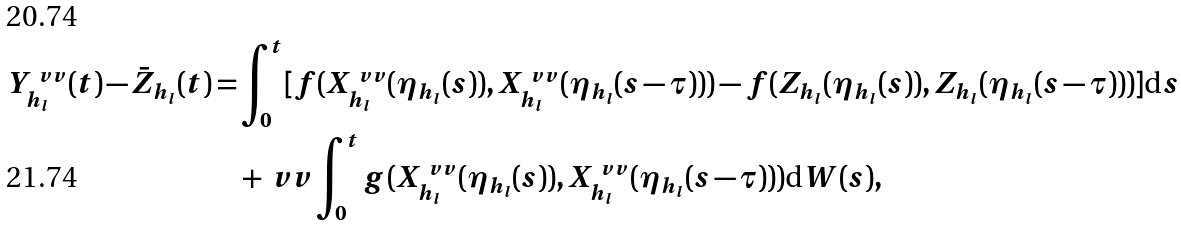Convert formula to latex. <formula><loc_0><loc_0><loc_500><loc_500>Y ^ { \ v v } _ { h _ { l } } ( t ) - \bar { Z } _ { h _ { l } } ( t ) = & \int _ { 0 } ^ { t } [ f ( X ^ { \ v v } _ { h _ { l } } ( \eta _ { h _ { l } } ( s ) ) , X ^ { \ v v } _ { h _ { l } } ( \eta _ { h _ { l } } ( s - \tau ) ) ) - f ( Z _ { h _ { l } } ( \eta _ { h _ { l } } ( s ) ) , Z _ { h _ { l } } ( \eta _ { h _ { l } } ( s - \tau ) ) ) ] { \mbox d } s \\ & + \ v v \int _ { 0 } ^ { t } g ( X ^ { \ v v } _ { h _ { l } } ( \eta _ { h _ { l } } ( s ) ) , X ^ { \ v v } _ { h _ { l } } ( \eta _ { h _ { l } } ( s - \tau ) ) ) { \mbox d } W ( s ) ,</formula> 